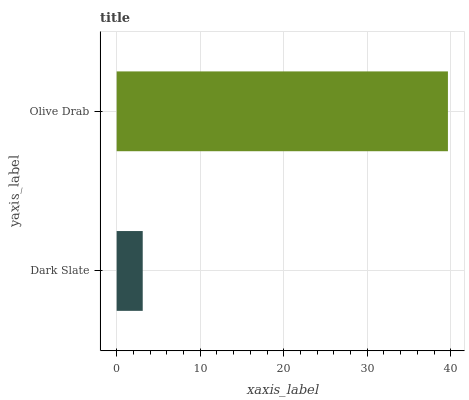Is Dark Slate the minimum?
Answer yes or no. Yes. Is Olive Drab the maximum?
Answer yes or no. Yes. Is Olive Drab the minimum?
Answer yes or no. No. Is Olive Drab greater than Dark Slate?
Answer yes or no. Yes. Is Dark Slate less than Olive Drab?
Answer yes or no. Yes. Is Dark Slate greater than Olive Drab?
Answer yes or no. No. Is Olive Drab less than Dark Slate?
Answer yes or no. No. Is Olive Drab the high median?
Answer yes or no. Yes. Is Dark Slate the low median?
Answer yes or no. Yes. Is Dark Slate the high median?
Answer yes or no. No. Is Olive Drab the low median?
Answer yes or no. No. 